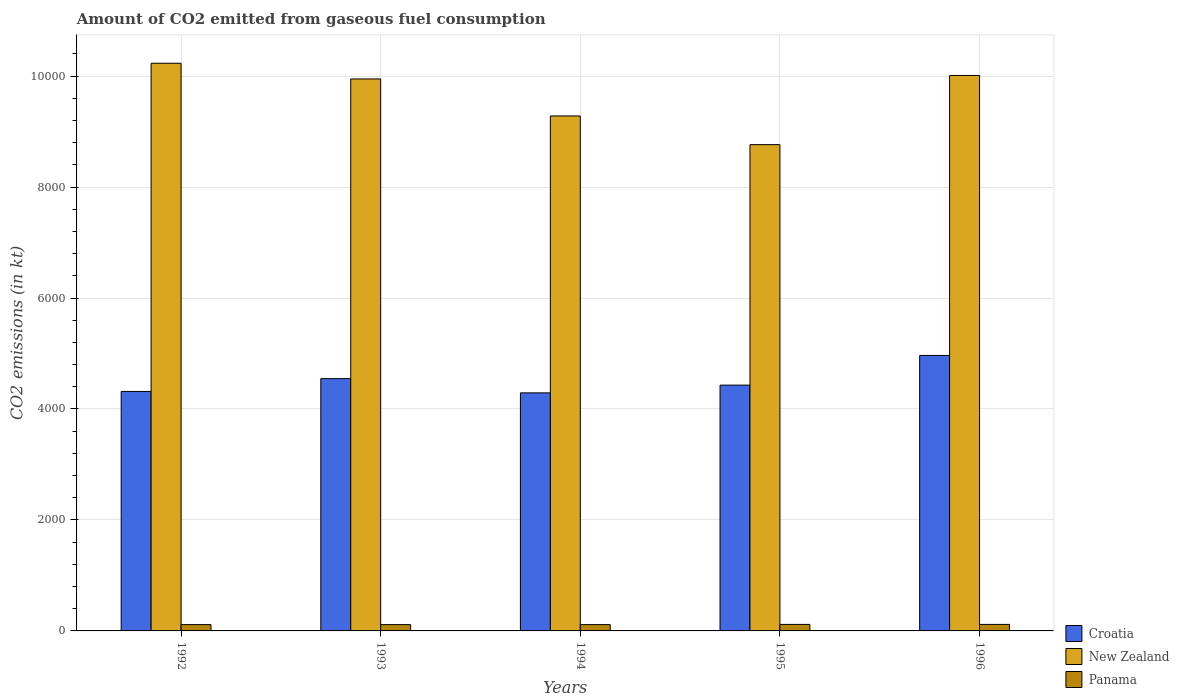Are the number of bars per tick equal to the number of legend labels?
Your answer should be very brief. Yes. How many bars are there on the 2nd tick from the left?
Your response must be concise. 3. What is the amount of CO2 emitted in Panama in 1993?
Your response must be concise. 113.68. Across all years, what is the maximum amount of CO2 emitted in New Zealand?
Keep it short and to the point. 1.02e+04. Across all years, what is the minimum amount of CO2 emitted in New Zealand?
Your response must be concise. 8764.13. In which year was the amount of CO2 emitted in Panama maximum?
Provide a short and direct response. 1995. In which year was the amount of CO2 emitted in New Zealand minimum?
Make the answer very short. 1995. What is the total amount of CO2 emitted in New Zealand in the graph?
Give a very brief answer. 4.82e+04. What is the difference between the amount of CO2 emitted in New Zealand in 1994 and that in 1995?
Provide a short and direct response. 517.05. What is the difference between the amount of CO2 emitted in Panama in 1996 and the amount of CO2 emitted in New Zealand in 1995?
Provide a succinct answer. -8646.79. What is the average amount of CO2 emitted in Croatia per year?
Keep it short and to the point. 4509.68. In the year 1994, what is the difference between the amount of CO2 emitted in New Zealand and amount of CO2 emitted in Panama?
Keep it short and to the point. 9167.5. What is the ratio of the amount of CO2 emitted in New Zealand in 1994 to that in 1996?
Offer a terse response. 0.93. Is the difference between the amount of CO2 emitted in New Zealand in 1992 and 1995 greater than the difference between the amount of CO2 emitted in Panama in 1992 and 1995?
Keep it short and to the point. Yes. What is the difference between the highest and the second highest amount of CO2 emitted in New Zealand?
Offer a terse response. 220.02. What is the difference between the highest and the lowest amount of CO2 emitted in New Zealand?
Give a very brief answer. 1466.8. Is the sum of the amount of CO2 emitted in Croatia in 1992 and 1996 greater than the maximum amount of CO2 emitted in Panama across all years?
Offer a terse response. Yes. What does the 3rd bar from the left in 1996 represents?
Keep it short and to the point. Panama. What does the 1st bar from the right in 1994 represents?
Provide a succinct answer. Panama. How many bars are there?
Keep it short and to the point. 15. How many years are there in the graph?
Offer a very short reply. 5. How many legend labels are there?
Give a very brief answer. 3. What is the title of the graph?
Your answer should be compact. Amount of CO2 emitted from gaseous fuel consumption. Does "Low income" appear as one of the legend labels in the graph?
Provide a short and direct response. No. What is the label or title of the Y-axis?
Offer a terse response. CO2 emissions (in kt). What is the CO2 emissions (in kt) in Croatia in 1992?
Give a very brief answer. 4316.06. What is the CO2 emissions (in kt) of New Zealand in 1992?
Ensure brevity in your answer.  1.02e+04. What is the CO2 emissions (in kt) of Panama in 1992?
Ensure brevity in your answer.  113.68. What is the CO2 emissions (in kt) in Croatia in 1993?
Keep it short and to the point. 4547.08. What is the CO2 emissions (in kt) in New Zealand in 1993?
Provide a short and direct response. 9948.57. What is the CO2 emissions (in kt) of Panama in 1993?
Offer a terse response. 113.68. What is the CO2 emissions (in kt) of Croatia in 1994?
Offer a very short reply. 4290.39. What is the CO2 emissions (in kt) of New Zealand in 1994?
Provide a short and direct response. 9281.18. What is the CO2 emissions (in kt) in Panama in 1994?
Keep it short and to the point. 113.68. What is the CO2 emissions (in kt) of Croatia in 1995?
Provide a short and direct response. 4429.74. What is the CO2 emissions (in kt) in New Zealand in 1995?
Your response must be concise. 8764.13. What is the CO2 emissions (in kt) in Panama in 1995?
Provide a succinct answer. 117.34. What is the CO2 emissions (in kt) of Croatia in 1996?
Offer a very short reply. 4965.12. What is the CO2 emissions (in kt) of New Zealand in 1996?
Give a very brief answer. 1.00e+04. What is the CO2 emissions (in kt) of Panama in 1996?
Provide a short and direct response. 117.34. Across all years, what is the maximum CO2 emissions (in kt) of Croatia?
Offer a terse response. 4965.12. Across all years, what is the maximum CO2 emissions (in kt) in New Zealand?
Ensure brevity in your answer.  1.02e+04. Across all years, what is the maximum CO2 emissions (in kt) of Panama?
Your answer should be compact. 117.34. Across all years, what is the minimum CO2 emissions (in kt) in Croatia?
Provide a short and direct response. 4290.39. Across all years, what is the minimum CO2 emissions (in kt) of New Zealand?
Offer a very short reply. 8764.13. Across all years, what is the minimum CO2 emissions (in kt) of Panama?
Your response must be concise. 113.68. What is the total CO2 emissions (in kt) of Croatia in the graph?
Your answer should be compact. 2.25e+04. What is the total CO2 emissions (in kt) in New Zealand in the graph?
Make the answer very short. 4.82e+04. What is the total CO2 emissions (in kt) of Panama in the graph?
Offer a terse response. 575.72. What is the difference between the CO2 emissions (in kt) in Croatia in 1992 and that in 1993?
Provide a succinct answer. -231.02. What is the difference between the CO2 emissions (in kt) of New Zealand in 1992 and that in 1993?
Make the answer very short. 282.36. What is the difference between the CO2 emissions (in kt) in Croatia in 1992 and that in 1994?
Provide a succinct answer. 25.67. What is the difference between the CO2 emissions (in kt) in New Zealand in 1992 and that in 1994?
Your answer should be compact. 949.75. What is the difference between the CO2 emissions (in kt) in Croatia in 1992 and that in 1995?
Your answer should be compact. -113.68. What is the difference between the CO2 emissions (in kt) of New Zealand in 1992 and that in 1995?
Your response must be concise. 1466.8. What is the difference between the CO2 emissions (in kt) in Panama in 1992 and that in 1995?
Your answer should be very brief. -3.67. What is the difference between the CO2 emissions (in kt) of Croatia in 1992 and that in 1996?
Your answer should be very brief. -649.06. What is the difference between the CO2 emissions (in kt) in New Zealand in 1992 and that in 1996?
Offer a very short reply. 220.02. What is the difference between the CO2 emissions (in kt) of Panama in 1992 and that in 1996?
Provide a succinct answer. -3.67. What is the difference between the CO2 emissions (in kt) in Croatia in 1993 and that in 1994?
Offer a very short reply. 256.69. What is the difference between the CO2 emissions (in kt) in New Zealand in 1993 and that in 1994?
Your answer should be very brief. 667.39. What is the difference between the CO2 emissions (in kt) of Croatia in 1993 and that in 1995?
Offer a very short reply. 117.34. What is the difference between the CO2 emissions (in kt) in New Zealand in 1993 and that in 1995?
Ensure brevity in your answer.  1184.44. What is the difference between the CO2 emissions (in kt) of Panama in 1993 and that in 1995?
Your response must be concise. -3.67. What is the difference between the CO2 emissions (in kt) in Croatia in 1993 and that in 1996?
Give a very brief answer. -418.04. What is the difference between the CO2 emissions (in kt) in New Zealand in 1993 and that in 1996?
Offer a very short reply. -62.34. What is the difference between the CO2 emissions (in kt) of Panama in 1993 and that in 1996?
Ensure brevity in your answer.  -3.67. What is the difference between the CO2 emissions (in kt) of Croatia in 1994 and that in 1995?
Give a very brief answer. -139.35. What is the difference between the CO2 emissions (in kt) of New Zealand in 1994 and that in 1995?
Your answer should be compact. 517.05. What is the difference between the CO2 emissions (in kt) in Panama in 1994 and that in 1995?
Provide a short and direct response. -3.67. What is the difference between the CO2 emissions (in kt) in Croatia in 1994 and that in 1996?
Offer a terse response. -674.73. What is the difference between the CO2 emissions (in kt) in New Zealand in 1994 and that in 1996?
Ensure brevity in your answer.  -729.73. What is the difference between the CO2 emissions (in kt) of Panama in 1994 and that in 1996?
Offer a terse response. -3.67. What is the difference between the CO2 emissions (in kt) in Croatia in 1995 and that in 1996?
Offer a very short reply. -535.38. What is the difference between the CO2 emissions (in kt) of New Zealand in 1995 and that in 1996?
Offer a very short reply. -1246.78. What is the difference between the CO2 emissions (in kt) of Panama in 1995 and that in 1996?
Provide a succinct answer. 0. What is the difference between the CO2 emissions (in kt) in Croatia in 1992 and the CO2 emissions (in kt) in New Zealand in 1993?
Make the answer very short. -5632.51. What is the difference between the CO2 emissions (in kt) of Croatia in 1992 and the CO2 emissions (in kt) of Panama in 1993?
Your answer should be very brief. 4202.38. What is the difference between the CO2 emissions (in kt) of New Zealand in 1992 and the CO2 emissions (in kt) of Panama in 1993?
Your answer should be very brief. 1.01e+04. What is the difference between the CO2 emissions (in kt) of Croatia in 1992 and the CO2 emissions (in kt) of New Zealand in 1994?
Your answer should be very brief. -4965.12. What is the difference between the CO2 emissions (in kt) of Croatia in 1992 and the CO2 emissions (in kt) of Panama in 1994?
Make the answer very short. 4202.38. What is the difference between the CO2 emissions (in kt) in New Zealand in 1992 and the CO2 emissions (in kt) in Panama in 1994?
Provide a succinct answer. 1.01e+04. What is the difference between the CO2 emissions (in kt) of Croatia in 1992 and the CO2 emissions (in kt) of New Zealand in 1995?
Your response must be concise. -4448.07. What is the difference between the CO2 emissions (in kt) in Croatia in 1992 and the CO2 emissions (in kt) in Panama in 1995?
Offer a terse response. 4198.72. What is the difference between the CO2 emissions (in kt) of New Zealand in 1992 and the CO2 emissions (in kt) of Panama in 1995?
Your answer should be compact. 1.01e+04. What is the difference between the CO2 emissions (in kt) of Croatia in 1992 and the CO2 emissions (in kt) of New Zealand in 1996?
Provide a short and direct response. -5694.85. What is the difference between the CO2 emissions (in kt) in Croatia in 1992 and the CO2 emissions (in kt) in Panama in 1996?
Offer a very short reply. 4198.72. What is the difference between the CO2 emissions (in kt) in New Zealand in 1992 and the CO2 emissions (in kt) in Panama in 1996?
Make the answer very short. 1.01e+04. What is the difference between the CO2 emissions (in kt) of Croatia in 1993 and the CO2 emissions (in kt) of New Zealand in 1994?
Your answer should be compact. -4734.1. What is the difference between the CO2 emissions (in kt) in Croatia in 1993 and the CO2 emissions (in kt) in Panama in 1994?
Keep it short and to the point. 4433.4. What is the difference between the CO2 emissions (in kt) in New Zealand in 1993 and the CO2 emissions (in kt) in Panama in 1994?
Provide a short and direct response. 9834.89. What is the difference between the CO2 emissions (in kt) of Croatia in 1993 and the CO2 emissions (in kt) of New Zealand in 1995?
Keep it short and to the point. -4217.05. What is the difference between the CO2 emissions (in kt) of Croatia in 1993 and the CO2 emissions (in kt) of Panama in 1995?
Your answer should be very brief. 4429.74. What is the difference between the CO2 emissions (in kt) in New Zealand in 1993 and the CO2 emissions (in kt) in Panama in 1995?
Your response must be concise. 9831.23. What is the difference between the CO2 emissions (in kt) in Croatia in 1993 and the CO2 emissions (in kt) in New Zealand in 1996?
Provide a short and direct response. -5463.83. What is the difference between the CO2 emissions (in kt) of Croatia in 1993 and the CO2 emissions (in kt) of Panama in 1996?
Your answer should be compact. 4429.74. What is the difference between the CO2 emissions (in kt) in New Zealand in 1993 and the CO2 emissions (in kt) in Panama in 1996?
Your answer should be very brief. 9831.23. What is the difference between the CO2 emissions (in kt) in Croatia in 1994 and the CO2 emissions (in kt) in New Zealand in 1995?
Your answer should be compact. -4473.74. What is the difference between the CO2 emissions (in kt) in Croatia in 1994 and the CO2 emissions (in kt) in Panama in 1995?
Make the answer very short. 4173.05. What is the difference between the CO2 emissions (in kt) of New Zealand in 1994 and the CO2 emissions (in kt) of Panama in 1995?
Give a very brief answer. 9163.83. What is the difference between the CO2 emissions (in kt) in Croatia in 1994 and the CO2 emissions (in kt) in New Zealand in 1996?
Your answer should be compact. -5720.52. What is the difference between the CO2 emissions (in kt) in Croatia in 1994 and the CO2 emissions (in kt) in Panama in 1996?
Your response must be concise. 4173.05. What is the difference between the CO2 emissions (in kt) in New Zealand in 1994 and the CO2 emissions (in kt) in Panama in 1996?
Offer a very short reply. 9163.83. What is the difference between the CO2 emissions (in kt) of Croatia in 1995 and the CO2 emissions (in kt) of New Zealand in 1996?
Give a very brief answer. -5581.17. What is the difference between the CO2 emissions (in kt) of Croatia in 1995 and the CO2 emissions (in kt) of Panama in 1996?
Ensure brevity in your answer.  4312.39. What is the difference between the CO2 emissions (in kt) of New Zealand in 1995 and the CO2 emissions (in kt) of Panama in 1996?
Provide a succinct answer. 8646.79. What is the average CO2 emissions (in kt) in Croatia per year?
Offer a very short reply. 4509.68. What is the average CO2 emissions (in kt) in New Zealand per year?
Offer a very short reply. 9647.14. What is the average CO2 emissions (in kt) in Panama per year?
Make the answer very short. 115.14. In the year 1992, what is the difference between the CO2 emissions (in kt) in Croatia and CO2 emissions (in kt) in New Zealand?
Give a very brief answer. -5914.87. In the year 1992, what is the difference between the CO2 emissions (in kt) in Croatia and CO2 emissions (in kt) in Panama?
Keep it short and to the point. 4202.38. In the year 1992, what is the difference between the CO2 emissions (in kt) of New Zealand and CO2 emissions (in kt) of Panama?
Your answer should be compact. 1.01e+04. In the year 1993, what is the difference between the CO2 emissions (in kt) in Croatia and CO2 emissions (in kt) in New Zealand?
Make the answer very short. -5401.49. In the year 1993, what is the difference between the CO2 emissions (in kt) of Croatia and CO2 emissions (in kt) of Panama?
Your answer should be very brief. 4433.4. In the year 1993, what is the difference between the CO2 emissions (in kt) in New Zealand and CO2 emissions (in kt) in Panama?
Offer a terse response. 9834.89. In the year 1994, what is the difference between the CO2 emissions (in kt) of Croatia and CO2 emissions (in kt) of New Zealand?
Your answer should be very brief. -4990.79. In the year 1994, what is the difference between the CO2 emissions (in kt) of Croatia and CO2 emissions (in kt) of Panama?
Offer a terse response. 4176.71. In the year 1994, what is the difference between the CO2 emissions (in kt) of New Zealand and CO2 emissions (in kt) of Panama?
Provide a succinct answer. 9167.5. In the year 1995, what is the difference between the CO2 emissions (in kt) in Croatia and CO2 emissions (in kt) in New Zealand?
Keep it short and to the point. -4334.39. In the year 1995, what is the difference between the CO2 emissions (in kt) in Croatia and CO2 emissions (in kt) in Panama?
Provide a short and direct response. 4312.39. In the year 1995, what is the difference between the CO2 emissions (in kt) in New Zealand and CO2 emissions (in kt) in Panama?
Your response must be concise. 8646.79. In the year 1996, what is the difference between the CO2 emissions (in kt) of Croatia and CO2 emissions (in kt) of New Zealand?
Your response must be concise. -5045.79. In the year 1996, what is the difference between the CO2 emissions (in kt) of Croatia and CO2 emissions (in kt) of Panama?
Ensure brevity in your answer.  4847.77. In the year 1996, what is the difference between the CO2 emissions (in kt) in New Zealand and CO2 emissions (in kt) in Panama?
Provide a succinct answer. 9893.57. What is the ratio of the CO2 emissions (in kt) in Croatia in 1992 to that in 1993?
Your response must be concise. 0.95. What is the ratio of the CO2 emissions (in kt) in New Zealand in 1992 to that in 1993?
Offer a very short reply. 1.03. What is the ratio of the CO2 emissions (in kt) of New Zealand in 1992 to that in 1994?
Your answer should be compact. 1.1. What is the ratio of the CO2 emissions (in kt) in Panama in 1992 to that in 1994?
Provide a succinct answer. 1. What is the ratio of the CO2 emissions (in kt) of Croatia in 1992 to that in 1995?
Provide a succinct answer. 0.97. What is the ratio of the CO2 emissions (in kt) in New Zealand in 1992 to that in 1995?
Offer a very short reply. 1.17. What is the ratio of the CO2 emissions (in kt) of Panama in 1992 to that in 1995?
Ensure brevity in your answer.  0.97. What is the ratio of the CO2 emissions (in kt) of Croatia in 1992 to that in 1996?
Provide a short and direct response. 0.87. What is the ratio of the CO2 emissions (in kt) in Panama in 1992 to that in 1996?
Keep it short and to the point. 0.97. What is the ratio of the CO2 emissions (in kt) in Croatia in 1993 to that in 1994?
Provide a succinct answer. 1.06. What is the ratio of the CO2 emissions (in kt) of New Zealand in 1993 to that in 1994?
Provide a succinct answer. 1.07. What is the ratio of the CO2 emissions (in kt) of Panama in 1993 to that in 1994?
Offer a terse response. 1. What is the ratio of the CO2 emissions (in kt) of Croatia in 1993 to that in 1995?
Provide a short and direct response. 1.03. What is the ratio of the CO2 emissions (in kt) of New Zealand in 1993 to that in 1995?
Your answer should be very brief. 1.14. What is the ratio of the CO2 emissions (in kt) in Panama in 1993 to that in 1995?
Your answer should be very brief. 0.97. What is the ratio of the CO2 emissions (in kt) of Croatia in 1993 to that in 1996?
Give a very brief answer. 0.92. What is the ratio of the CO2 emissions (in kt) of Panama in 1993 to that in 1996?
Make the answer very short. 0.97. What is the ratio of the CO2 emissions (in kt) in Croatia in 1994 to that in 1995?
Keep it short and to the point. 0.97. What is the ratio of the CO2 emissions (in kt) in New Zealand in 1994 to that in 1995?
Give a very brief answer. 1.06. What is the ratio of the CO2 emissions (in kt) of Panama in 1994 to that in 1995?
Provide a succinct answer. 0.97. What is the ratio of the CO2 emissions (in kt) of Croatia in 1994 to that in 1996?
Keep it short and to the point. 0.86. What is the ratio of the CO2 emissions (in kt) in New Zealand in 1994 to that in 1996?
Your response must be concise. 0.93. What is the ratio of the CO2 emissions (in kt) of Panama in 1994 to that in 1996?
Make the answer very short. 0.97. What is the ratio of the CO2 emissions (in kt) of Croatia in 1995 to that in 1996?
Keep it short and to the point. 0.89. What is the ratio of the CO2 emissions (in kt) in New Zealand in 1995 to that in 1996?
Ensure brevity in your answer.  0.88. What is the ratio of the CO2 emissions (in kt) in Panama in 1995 to that in 1996?
Provide a short and direct response. 1. What is the difference between the highest and the second highest CO2 emissions (in kt) of Croatia?
Make the answer very short. 418.04. What is the difference between the highest and the second highest CO2 emissions (in kt) of New Zealand?
Make the answer very short. 220.02. What is the difference between the highest and the lowest CO2 emissions (in kt) of Croatia?
Offer a terse response. 674.73. What is the difference between the highest and the lowest CO2 emissions (in kt) in New Zealand?
Offer a very short reply. 1466.8. What is the difference between the highest and the lowest CO2 emissions (in kt) in Panama?
Your answer should be compact. 3.67. 